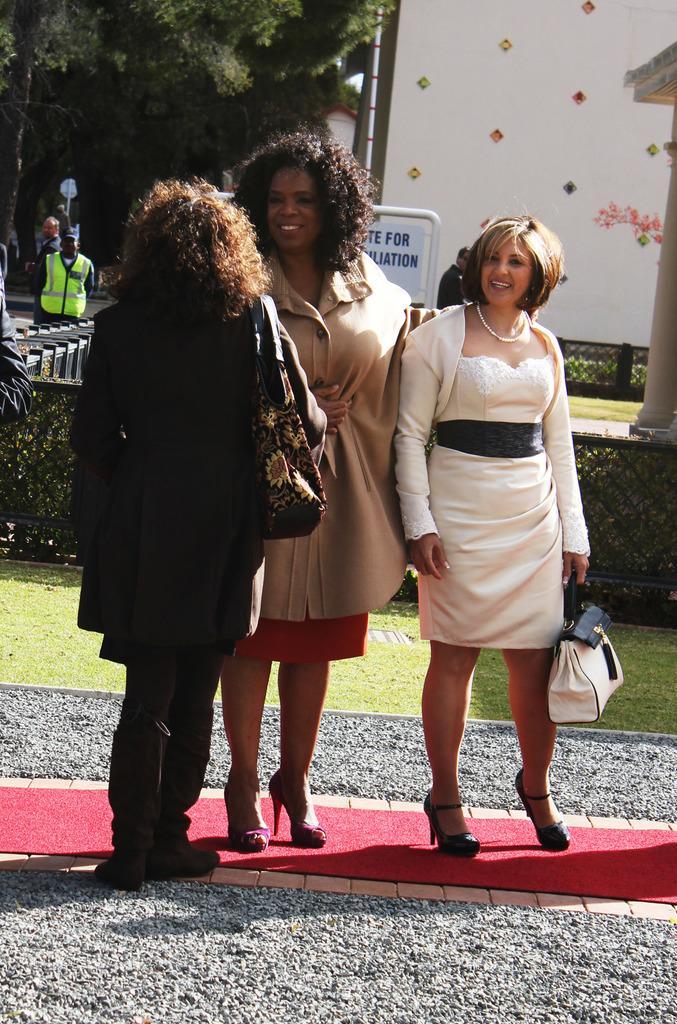In one or two sentences, can you explain what this image depicts? In this picture there are three woman standing on a red carpet and there are small rocks on either sides of them and there is a fence,building,trees and few other persons in the background. 